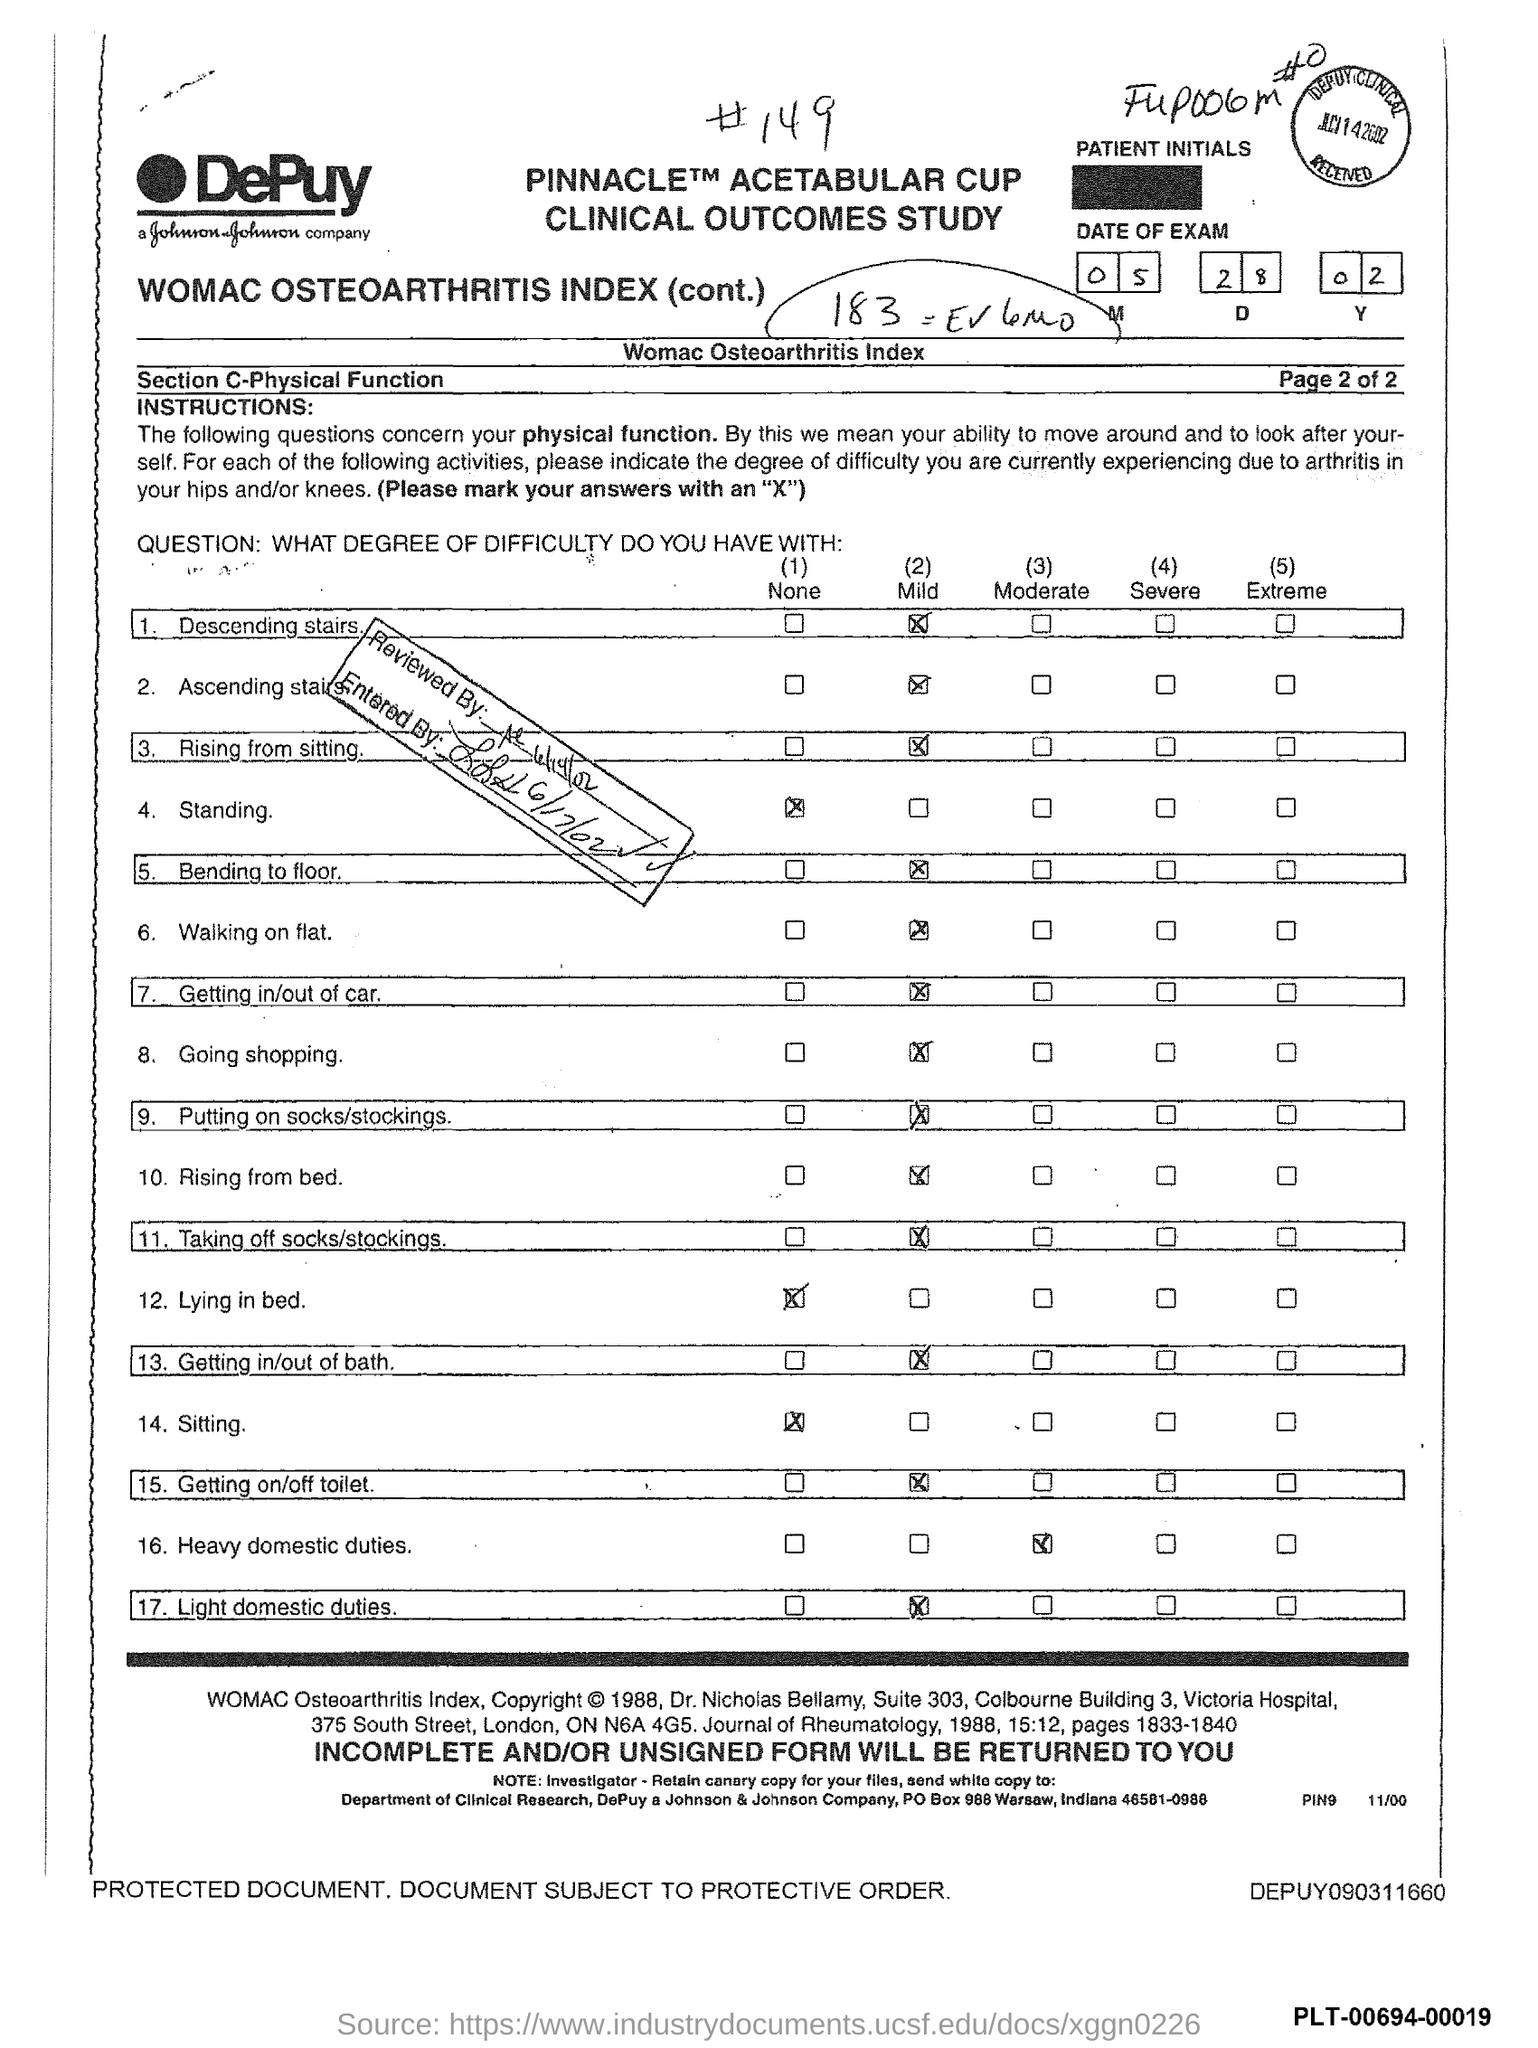What is the date of exam mentioned in the document?
Keep it short and to the point. 05 28 02. 